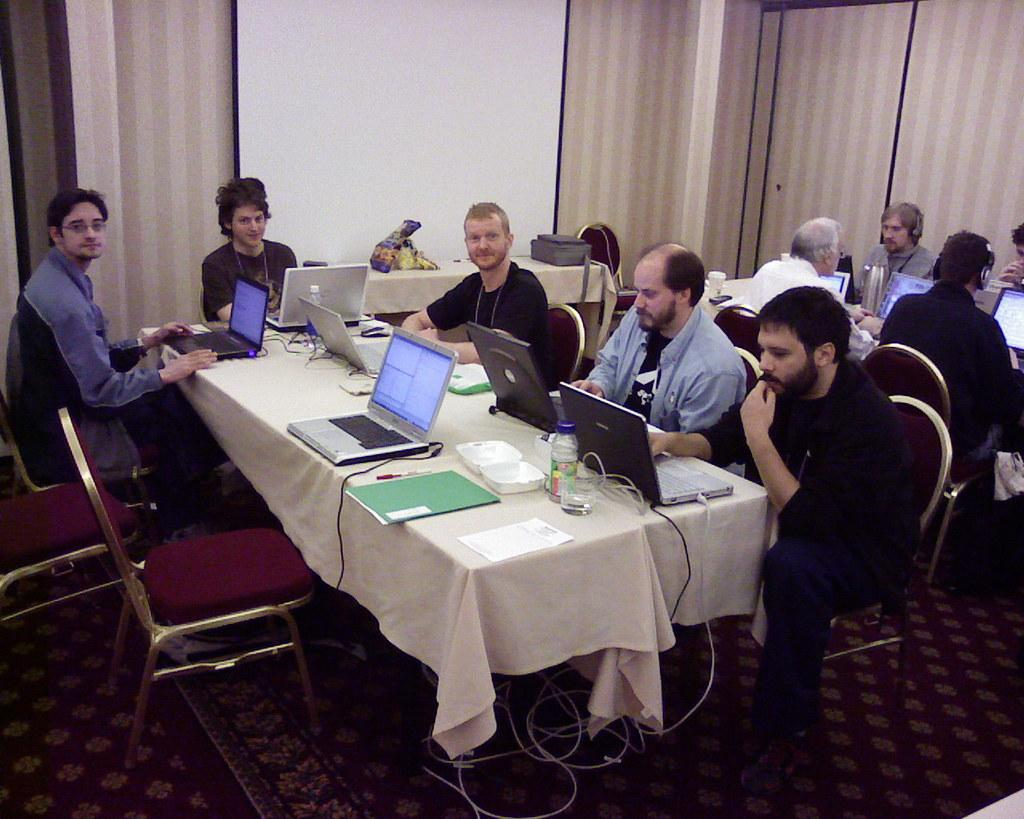What can be seen in the background of the image? There is a wall and cupboards in the background of the image. What are the persons in the image doing? The persons are sitting on chairs in front of a table. What objects are on the table? There are laptops on the table. What type of flooring is present in the image? There is a floor carpet in the image. Can you describe the slope of the zephyr in the image? There is no slope or zephyr present in the image. What is an example of a person sitting on a chair in the image? It is not necessary to provide an example, as there are already persons sitting on chairs in the image. 